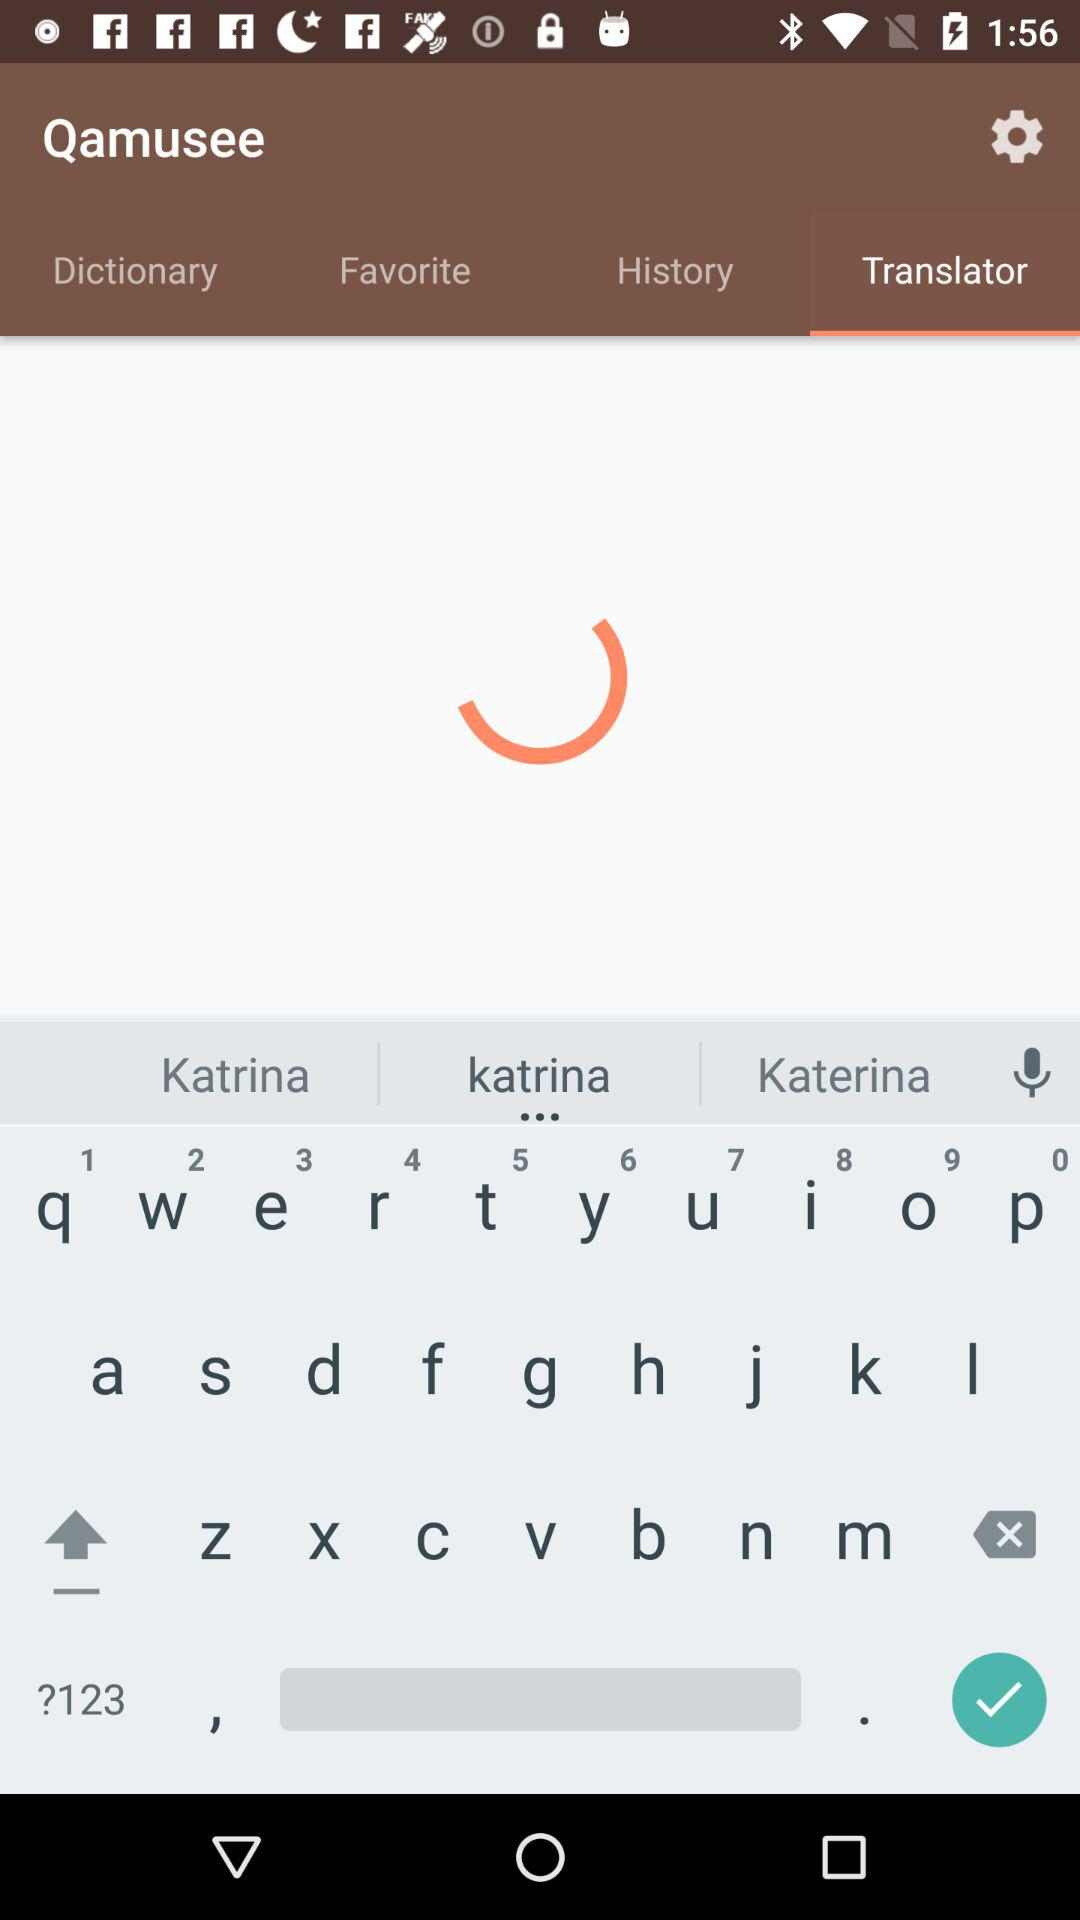What is the selected tab? The selected tab is "Translator". 